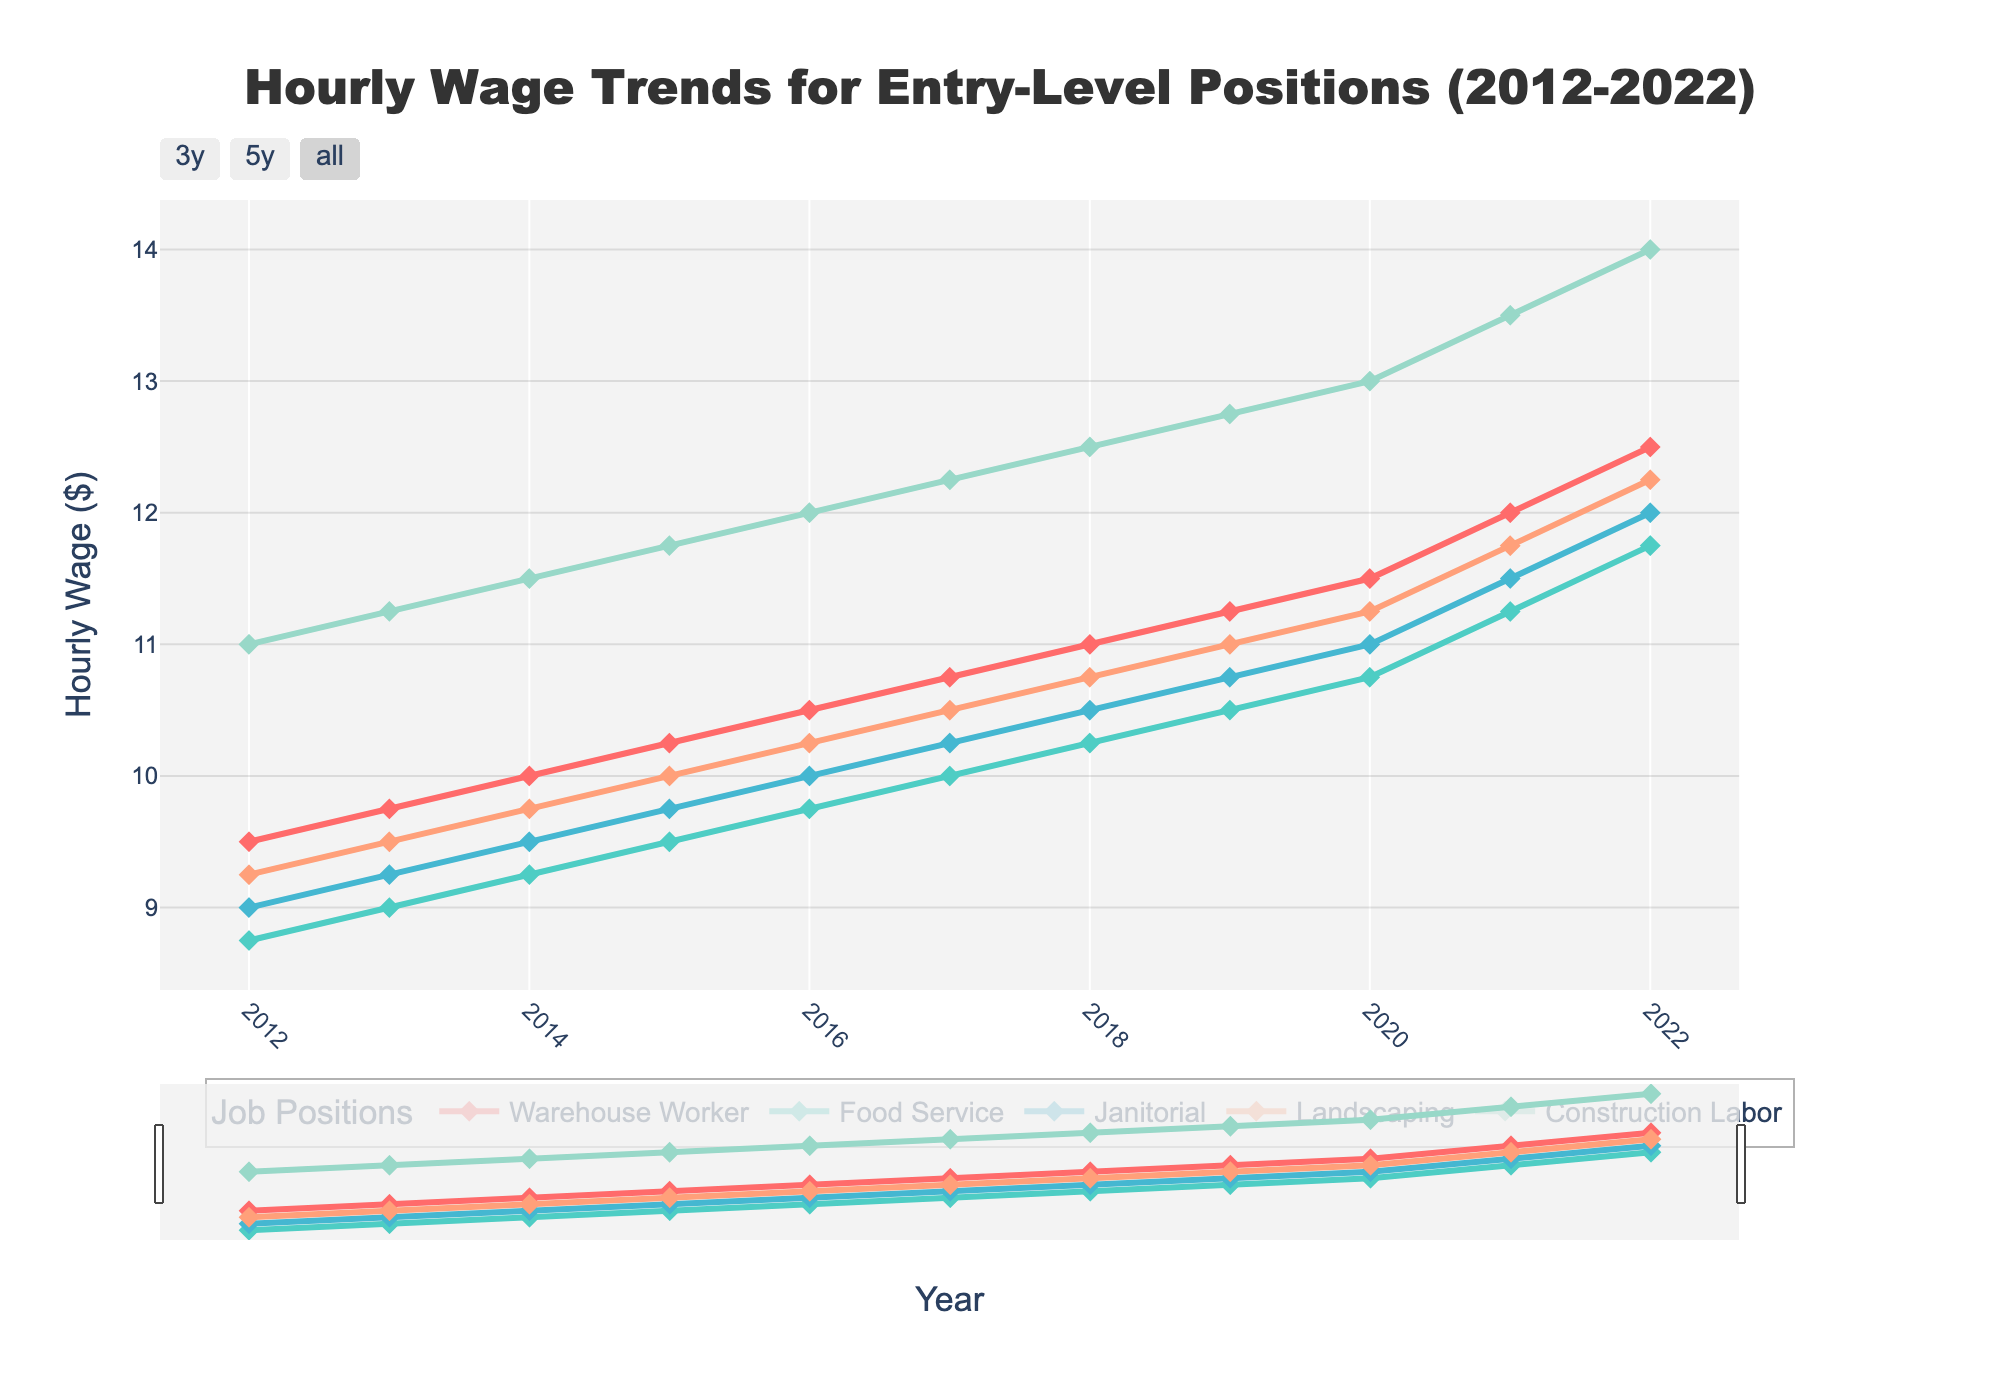What was the hourly wage for Warehouse Worker and Food Service in 2012? Look at the 2012 data points on the line chart for Warehouse Worker and Food Service. The wages are $9.50 and $8.75 respectively.
Answer: Warehouse Worker: $9.50, Food Service: $8.75 How did the hourly wage for Janitorial change from 2015 to 2020? Find the hourly wage for Janitorial in 2015 and 2020 on the graph. Subtract the 2015 value from the 2020 value. The wages are $9.75 in 2015 and $11.00 in 2020, so the difference is $11.00 - $9.75.
Answer: Increased by $1.25 Which job position had the highest hourly wage in 2022? Look at the 2022 data points for all job positions and find which one has the highest value. The Construction Labor line peaks at $14.00 in 2022.
Answer: Construction Labor What is the average hourly wage for Landscaping in the years 2012, 2016, and 2020? Find the hourly wage for Landscaping in 2012, 2016, and 2020. Sum these values and divide by the number of years. The wages are $9.25, $10.25, and $11.25 respectively. The sum is $9.25 + $10.25 + $11.25 = $30.75. The average is $30.75 / 3.
Answer: $10.25 Which job position had a greater increase in hourly wages between 2012 and 2022: Food Service or Janitorial? Calculate the difference in hourly wage for Food Service and Janitorial between 2012 and 2022. For Food Service, it's $11.75 - $8.75 = $3.00. For Janitorial, it's $12.00 - $9.00 = $3.00. Both had the same increase.
Answer: Both had the same increase of $3.00 What was the range of hourly wages for Construction Labor over the period 2012-2022? Identify the minimum and maximum hourly wages for Construction Labor from 2012 to 2022 on the graph. The minimum is $11.00 and the maximum is $14.00. The range is $14.00 - $11.00.
Answer: $3.00 In which year did Landscaping wages surpass $11.00 for the first time? Look at the Landscaping wage trend and identify the first year it surpasses $11.00. It occurs in 2021.
Answer: 2021 Between 2017 and 2018, which job had the greatest absolute increase in hourly wage? Find the increase in hourly wage for each job between 2017 and 2018 by subtracting the 2017 value from the 2018 value. Warehouse Worker increases by $0.25, Food Service by $0.25, Janitorial by $0.25, Landscaping by $0.25, and Construction Labor by $0.25. All increases are the same.
Answer: All had the same increase How does the growth trend of Food Service wages compare to Construction Labor wages from 2012 to 2022? Compare the slope of the wage lines from 2012 to 2022 for Food Service and Construction Labor. Both lines trend upward, but Construction Labor grows faster. The wage increase for Construction Labor is from $11.00 to $14.00 ($3.00), while for Food Service, it's from $8.75 to $11.75 ($3.00). Both have the same absolute increase but Construction Labor started higher.
Answer: Similar upward trend; Construction Labor grows faster in relative terms 